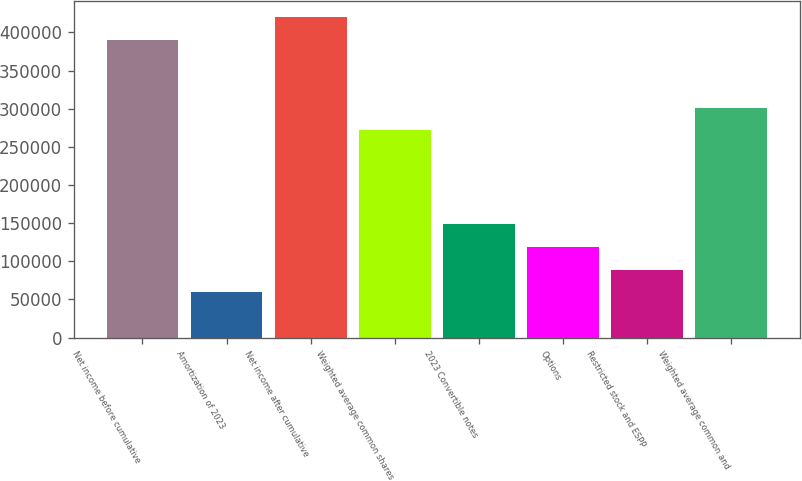Convert chart. <chart><loc_0><loc_0><loc_500><loc_500><bar_chart><fcel>Net income before cumulative<fcel>Amortization of 2023<fcel>Net income after cumulative<fcel>Weighted average common shares<fcel>2023 Convertible notes<fcel>Options<fcel>Restricted stock and ESPP<fcel>Weighted average common and<nl><fcel>390306<fcel>59426.5<fcel>420018<fcel>271455<fcel>148565<fcel>118852<fcel>89139.2<fcel>301168<nl></chart> 